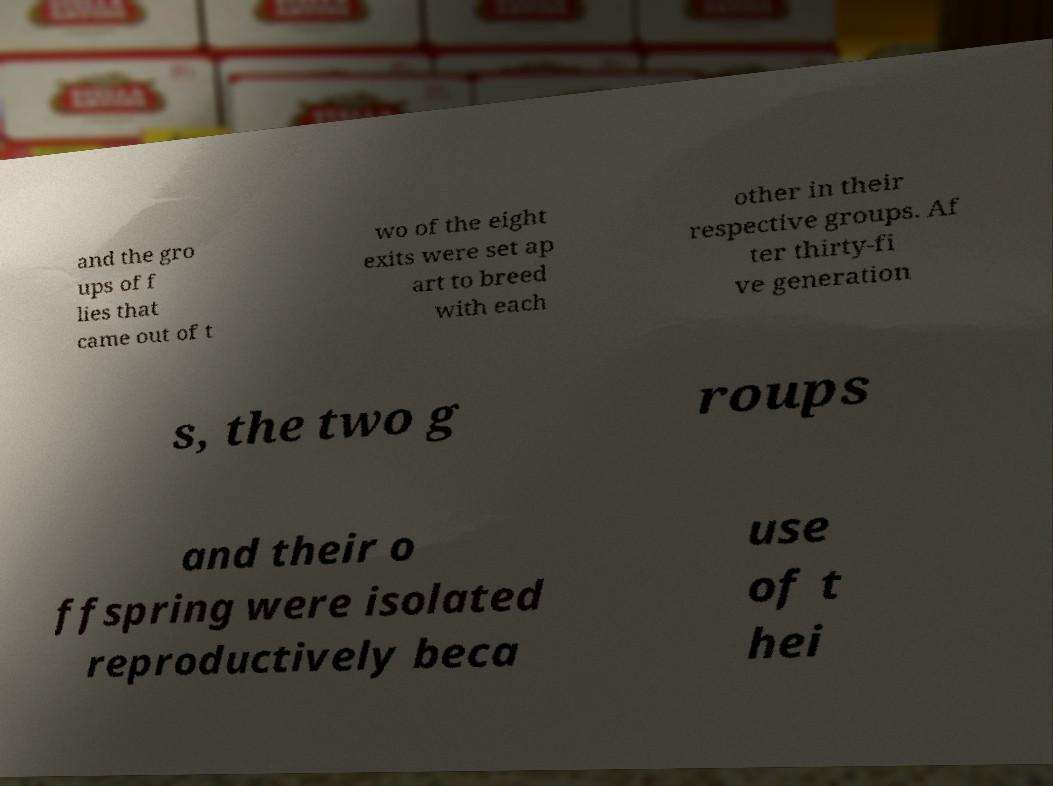There's text embedded in this image that I need extracted. Can you transcribe it verbatim? and the gro ups of f lies that came out of t wo of the eight exits were set ap art to breed with each other in their respective groups. Af ter thirty-fi ve generation s, the two g roups and their o ffspring were isolated reproductively beca use of t hei 